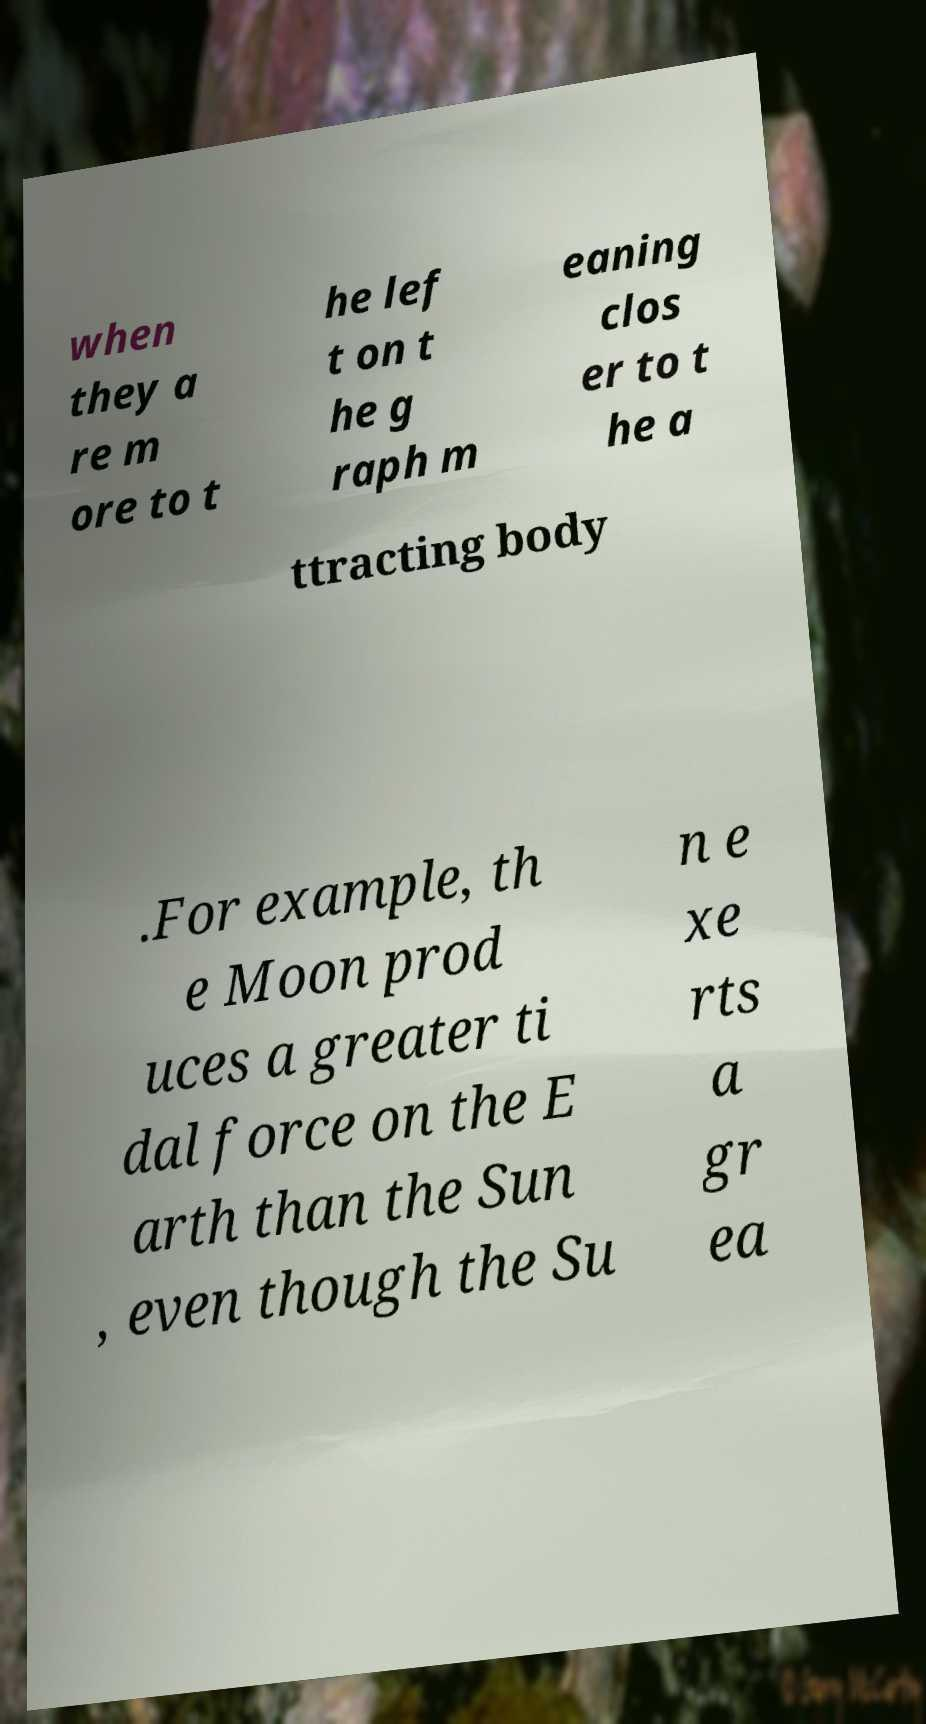Please read and relay the text visible in this image. What does it say? when they a re m ore to t he lef t on t he g raph m eaning clos er to t he a ttracting body .For example, th e Moon prod uces a greater ti dal force on the E arth than the Sun , even though the Su n e xe rts a gr ea 